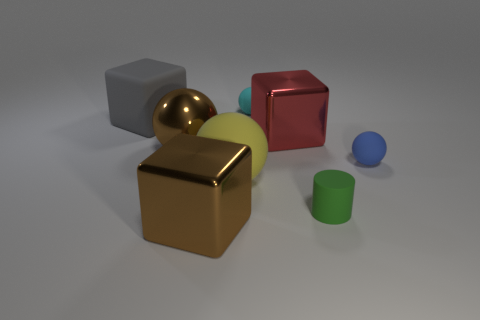Add 1 brown spheres. How many objects exist? 9 Subtract all cubes. How many objects are left? 5 Subtract 1 cyan balls. How many objects are left? 7 Subtract all brown metallic objects. Subtract all red matte spheres. How many objects are left? 6 Add 4 big brown metal cubes. How many big brown metal cubes are left? 5 Add 4 large cyan matte spheres. How many large cyan matte spheres exist? 4 